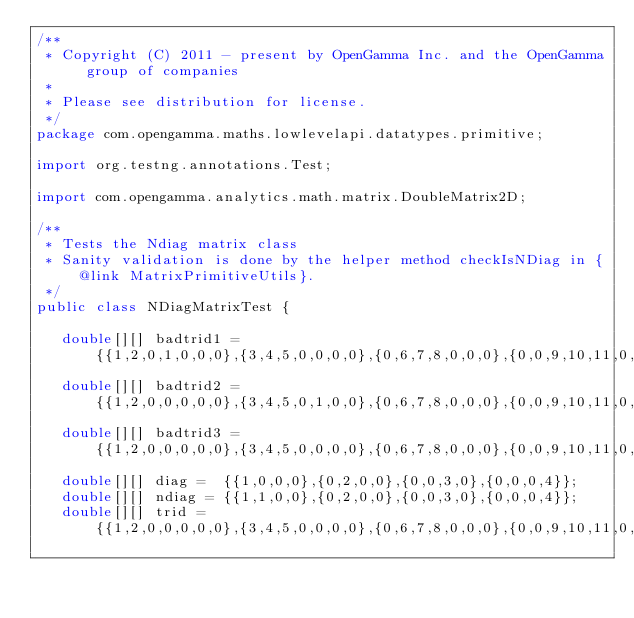<code> <loc_0><loc_0><loc_500><loc_500><_Java_>/**
 * Copyright (C) 2011 - present by OpenGamma Inc. and the OpenGamma group of companies
 *
 * Please see distribution for license.
 */
package com.opengamma.maths.lowlevelapi.datatypes.primitive;

import org.testng.annotations.Test;

import com.opengamma.analytics.math.matrix.DoubleMatrix2D;

/**
 * Tests the Ndiag matrix class
 * Sanity validation is done by the helper method checkIsNDiag in {@link MatrixPrimitiveUtils}.
 */
public class NDiagMatrixTest {

   double[][] badtrid1 = {{1,2,0,1,0,0,0},{3,4,5,0,0,0,0},{0,6,7,8,0,0,0},{0,0,9,10,11,0,0},{0,0,0,12,13,14,0},{0,0,0,0,15,16,17},{0,0,0,0,0,18,19}};
   double[][] badtrid2 = {{1,2,0,0,0,0,0},{3,4,5,0,1,0,0},{0,6,7,8,0,0,0},{0,0,9,10,11,0,0},{0,0,0,12,13,14,0},{0,0,0,0,15,16,17},{0,0,0,0,0,18,19}};
   double[][] badtrid3 = {{1,2,0,0,0,0,0},{3,4,5,0,0,0,0},{0,6,7,8,0,0,0},{0,0,9,10,11,0,0},{0,0,0,12,13,14,0},{0,0,0,0,15,16,17},{0,0,1,0,0,18,19}};
   double[][] diag =  {{1,0,0,0},{0,2,0,0},{0,0,3,0},{0,0,0,4}};
   double[][] ndiag = {{1,1,0,0},{0,2,0,0},{0,0,3,0},{0,0,0,4}};
   double[][] trid = {{1,2,0,0,0,0,0},{3,4,5,0,0,0,0},{0,6,7,8,0,0,0},{0,0,9,10,11,0,0},{0,0,0,12,13,14,0},{0,0,0,0,15,16,17},{0,0,0,0,0,18,19}};</code> 